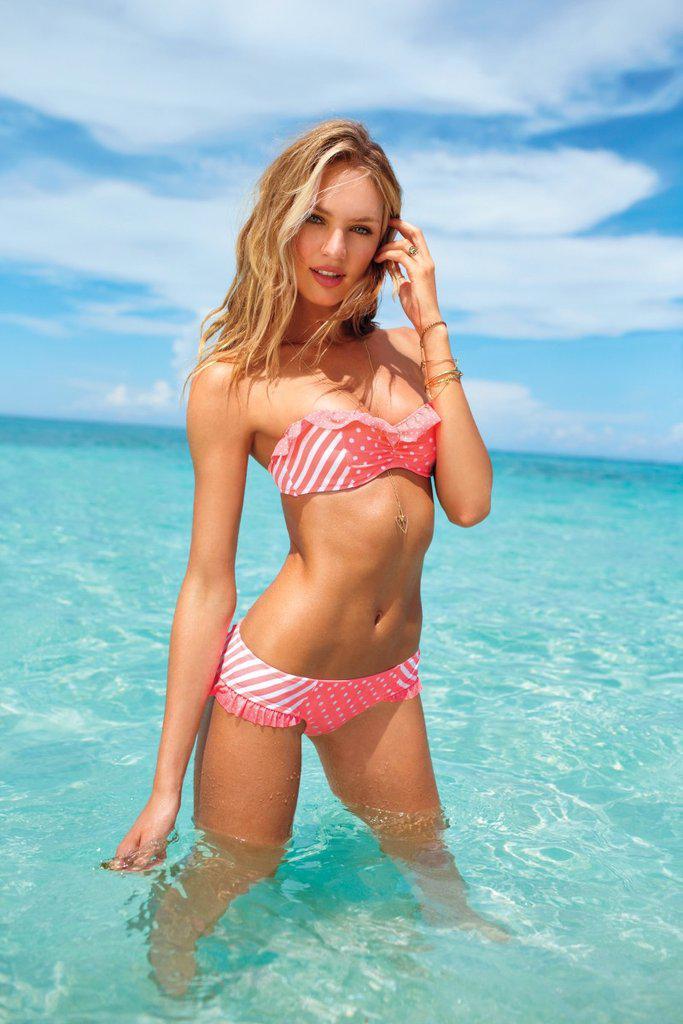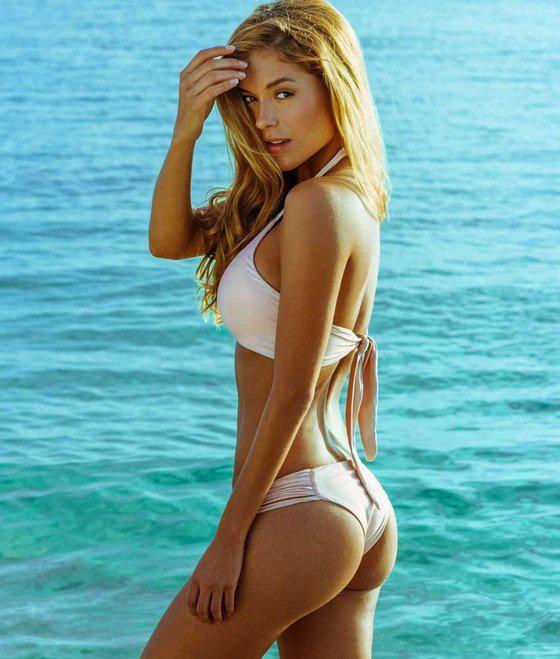The first image is the image on the left, the second image is the image on the right. Examine the images to the left and right. Is the description "The left and right image contains the same number of women in bikinis with at least one in all white." accurate? Answer yes or no. Yes. 